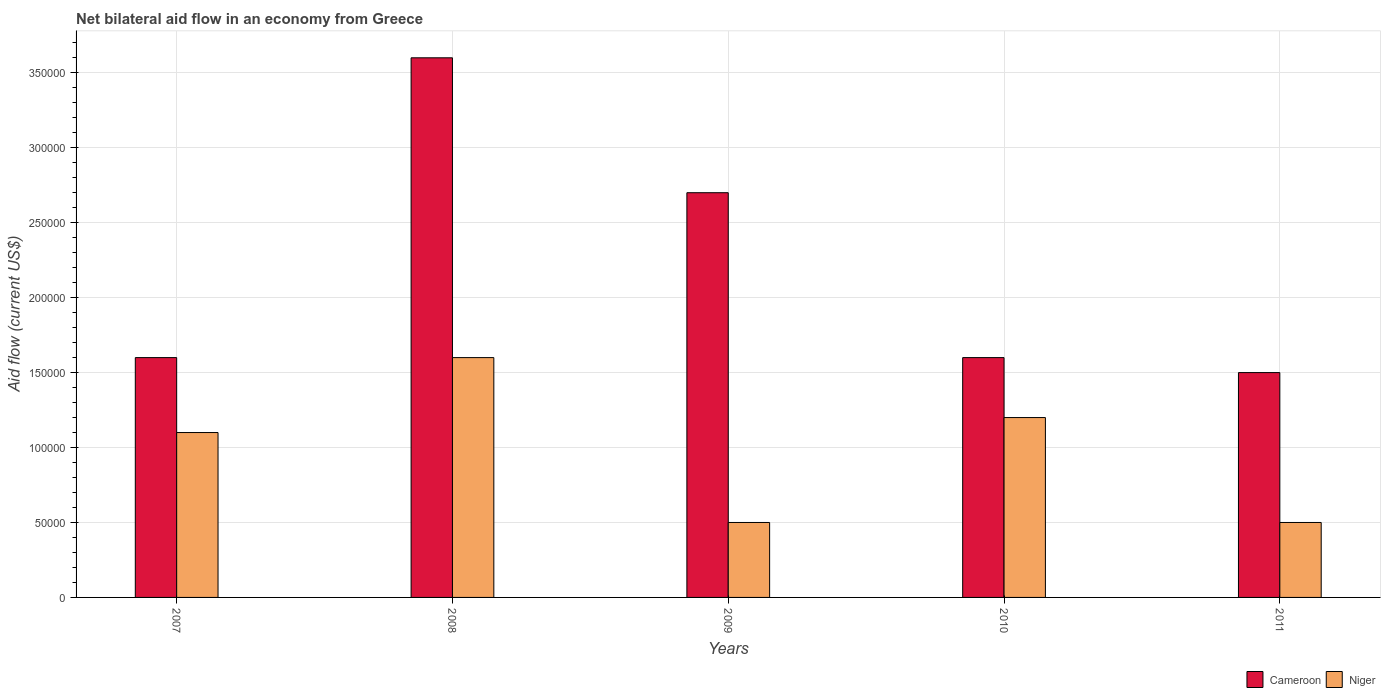How many different coloured bars are there?
Ensure brevity in your answer.  2. How many groups of bars are there?
Your response must be concise. 5. How many bars are there on the 2nd tick from the right?
Provide a succinct answer. 2. In how many cases, is the number of bars for a given year not equal to the number of legend labels?
Make the answer very short. 0. Across all years, what is the maximum net bilateral aid flow in Niger?
Your response must be concise. 1.60e+05. Across all years, what is the minimum net bilateral aid flow in Cameroon?
Your answer should be very brief. 1.50e+05. What is the total net bilateral aid flow in Cameroon in the graph?
Offer a very short reply. 1.10e+06. What is the difference between the net bilateral aid flow in Cameroon in 2008 and that in 2011?
Provide a succinct answer. 2.10e+05. What is the average net bilateral aid flow in Niger per year?
Provide a short and direct response. 9.80e+04. What is the ratio of the net bilateral aid flow in Niger in 2009 to that in 2010?
Offer a very short reply. 0.42. Is the net bilateral aid flow in Niger in 2010 less than that in 2011?
Offer a very short reply. No. Is the difference between the net bilateral aid flow in Niger in 2007 and 2008 greater than the difference between the net bilateral aid flow in Cameroon in 2007 and 2008?
Give a very brief answer. Yes. What is the difference between the highest and the lowest net bilateral aid flow in Cameroon?
Your answer should be compact. 2.10e+05. What does the 2nd bar from the left in 2011 represents?
Offer a very short reply. Niger. What does the 2nd bar from the right in 2007 represents?
Keep it short and to the point. Cameroon. How many bars are there?
Give a very brief answer. 10. What is the difference between two consecutive major ticks on the Y-axis?
Keep it short and to the point. 5.00e+04. Are the values on the major ticks of Y-axis written in scientific E-notation?
Give a very brief answer. No. Does the graph contain grids?
Offer a very short reply. Yes. Where does the legend appear in the graph?
Provide a succinct answer. Bottom right. How many legend labels are there?
Give a very brief answer. 2. What is the title of the graph?
Your response must be concise. Net bilateral aid flow in an economy from Greece. Does "Uganda" appear as one of the legend labels in the graph?
Your answer should be compact. No. What is the label or title of the X-axis?
Make the answer very short. Years. What is the Aid flow (current US$) in Cameroon in 2007?
Give a very brief answer. 1.60e+05. What is the Aid flow (current US$) in Cameroon in 2008?
Ensure brevity in your answer.  3.60e+05. What is the Aid flow (current US$) of Niger in 2008?
Your answer should be very brief. 1.60e+05. What is the Aid flow (current US$) of Cameroon in 2009?
Provide a short and direct response. 2.70e+05. What is the Aid flow (current US$) in Niger in 2009?
Offer a terse response. 5.00e+04. What is the Aid flow (current US$) of Cameroon in 2010?
Offer a terse response. 1.60e+05. What is the Aid flow (current US$) in Cameroon in 2011?
Make the answer very short. 1.50e+05. Across all years, what is the maximum Aid flow (current US$) in Cameroon?
Your answer should be very brief. 3.60e+05. Across all years, what is the maximum Aid flow (current US$) in Niger?
Give a very brief answer. 1.60e+05. Across all years, what is the minimum Aid flow (current US$) of Cameroon?
Keep it short and to the point. 1.50e+05. What is the total Aid flow (current US$) in Cameroon in the graph?
Your answer should be very brief. 1.10e+06. What is the difference between the Aid flow (current US$) of Cameroon in 2007 and that in 2008?
Provide a succinct answer. -2.00e+05. What is the difference between the Aid flow (current US$) in Cameroon in 2007 and that in 2009?
Provide a succinct answer. -1.10e+05. What is the difference between the Aid flow (current US$) of Niger in 2007 and that in 2010?
Your answer should be very brief. -10000. What is the difference between the Aid flow (current US$) of Cameroon in 2007 and that in 2011?
Ensure brevity in your answer.  10000. What is the difference between the Aid flow (current US$) in Niger in 2007 and that in 2011?
Make the answer very short. 6.00e+04. What is the difference between the Aid flow (current US$) of Niger in 2008 and that in 2009?
Keep it short and to the point. 1.10e+05. What is the difference between the Aid flow (current US$) in Niger in 2008 and that in 2010?
Give a very brief answer. 4.00e+04. What is the difference between the Aid flow (current US$) in Cameroon in 2008 and that in 2011?
Your response must be concise. 2.10e+05. What is the difference between the Aid flow (current US$) in Niger in 2009 and that in 2010?
Make the answer very short. -7.00e+04. What is the difference between the Aid flow (current US$) of Cameroon in 2009 and that in 2011?
Provide a short and direct response. 1.20e+05. What is the difference between the Aid flow (current US$) in Niger in 2010 and that in 2011?
Make the answer very short. 7.00e+04. What is the difference between the Aid flow (current US$) in Cameroon in 2007 and the Aid flow (current US$) in Niger in 2008?
Ensure brevity in your answer.  0. What is the difference between the Aid flow (current US$) of Cameroon in 2007 and the Aid flow (current US$) of Niger in 2010?
Provide a succinct answer. 4.00e+04. What is the difference between the Aid flow (current US$) in Cameroon in 2007 and the Aid flow (current US$) in Niger in 2011?
Your response must be concise. 1.10e+05. What is the difference between the Aid flow (current US$) in Cameroon in 2008 and the Aid flow (current US$) in Niger in 2010?
Your response must be concise. 2.40e+05. What is the average Aid flow (current US$) of Niger per year?
Ensure brevity in your answer.  9.80e+04. In the year 2007, what is the difference between the Aid flow (current US$) in Cameroon and Aid flow (current US$) in Niger?
Ensure brevity in your answer.  5.00e+04. In the year 2008, what is the difference between the Aid flow (current US$) in Cameroon and Aid flow (current US$) in Niger?
Offer a very short reply. 2.00e+05. What is the ratio of the Aid flow (current US$) of Cameroon in 2007 to that in 2008?
Provide a short and direct response. 0.44. What is the ratio of the Aid flow (current US$) of Niger in 2007 to that in 2008?
Ensure brevity in your answer.  0.69. What is the ratio of the Aid flow (current US$) in Cameroon in 2007 to that in 2009?
Give a very brief answer. 0.59. What is the ratio of the Aid flow (current US$) of Cameroon in 2007 to that in 2010?
Offer a very short reply. 1. What is the ratio of the Aid flow (current US$) in Niger in 2007 to that in 2010?
Your response must be concise. 0.92. What is the ratio of the Aid flow (current US$) in Cameroon in 2007 to that in 2011?
Offer a terse response. 1.07. What is the ratio of the Aid flow (current US$) of Niger in 2007 to that in 2011?
Offer a very short reply. 2.2. What is the ratio of the Aid flow (current US$) of Cameroon in 2008 to that in 2009?
Provide a succinct answer. 1.33. What is the ratio of the Aid flow (current US$) in Cameroon in 2008 to that in 2010?
Keep it short and to the point. 2.25. What is the ratio of the Aid flow (current US$) of Niger in 2008 to that in 2010?
Offer a terse response. 1.33. What is the ratio of the Aid flow (current US$) in Cameroon in 2009 to that in 2010?
Keep it short and to the point. 1.69. What is the ratio of the Aid flow (current US$) in Niger in 2009 to that in 2010?
Offer a very short reply. 0.42. What is the ratio of the Aid flow (current US$) in Cameroon in 2009 to that in 2011?
Your response must be concise. 1.8. What is the ratio of the Aid flow (current US$) of Niger in 2009 to that in 2011?
Provide a short and direct response. 1. What is the ratio of the Aid flow (current US$) in Cameroon in 2010 to that in 2011?
Your answer should be compact. 1.07. What is the ratio of the Aid flow (current US$) of Niger in 2010 to that in 2011?
Ensure brevity in your answer.  2.4. What is the difference between the highest and the second highest Aid flow (current US$) of Cameroon?
Your answer should be very brief. 9.00e+04. What is the difference between the highest and the lowest Aid flow (current US$) in Cameroon?
Provide a succinct answer. 2.10e+05. What is the difference between the highest and the lowest Aid flow (current US$) in Niger?
Provide a short and direct response. 1.10e+05. 